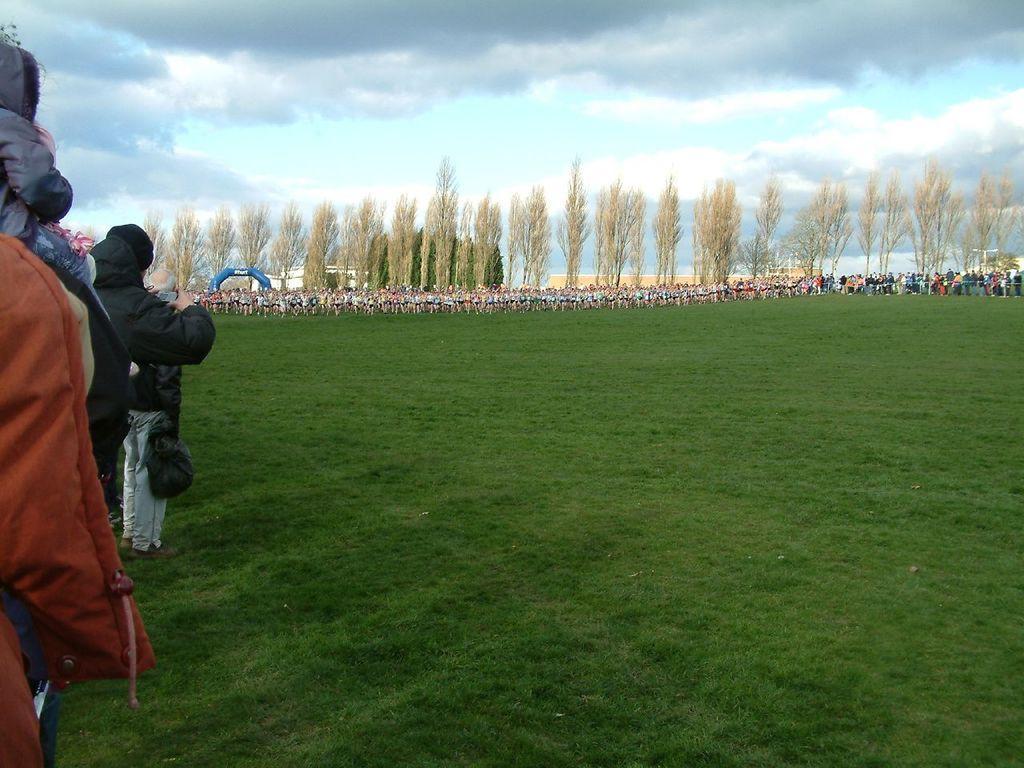Describe this image in one or two sentences. In this image I can see group of people standing, the person in front wearing black jacket, black bag. Background I can see few other persons standing, grass and trees in green color and the sky is in white color. 